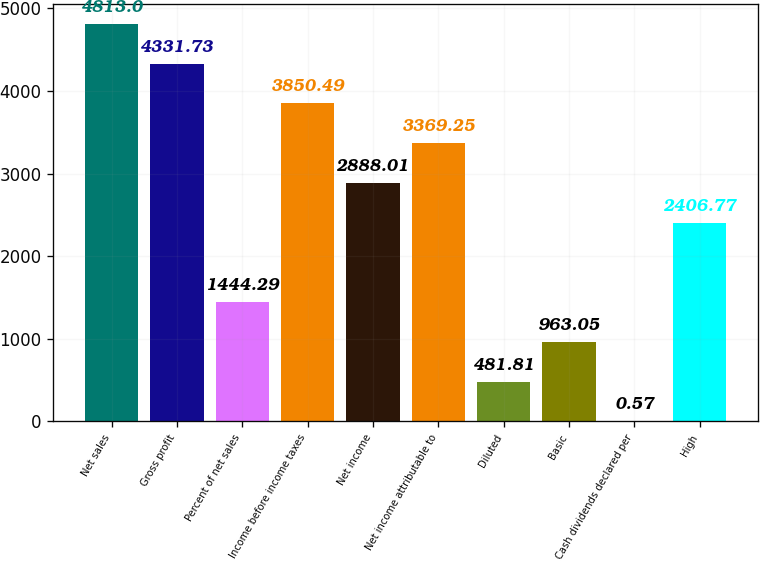<chart> <loc_0><loc_0><loc_500><loc_500><bar_chart><fcel>Net sales<fcel>Gross profit<fcel>Percent of net sales<fcel>Income before income taxes<fcel>Net income<fcel>Net income attributable to<fcel>Diluted<fcel>Basic<fcel>Cash dividends declared per<fcel>High<nl><fcel>4813<fcel>4331.73<fcel>1444.29<fcel>3850.49<fcel>2888.01<fcel>3369.25<fcel>481.81<fcel>963.05<fcel>0.57<fcel>2406.77<nl></chart> 